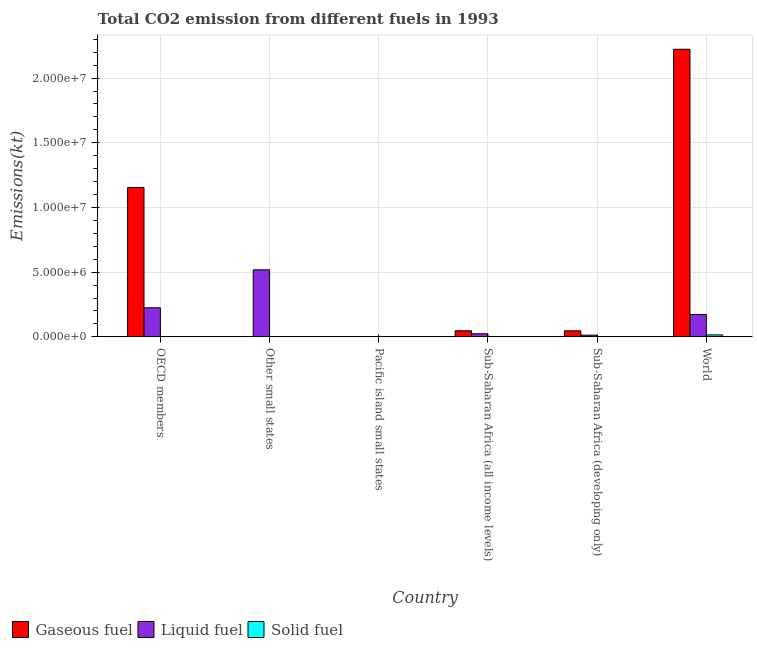How many different coloured bars are there?
Your answer should be compact. 3. How many groups of bars are there?
Provide a short and direct response. 6. Are the number of bars on each tick of the X-axis equal?
Provide a succinct answer. Yes. What is the label of the 2nd group of bars from the left?
Offer a terse response. Other small states. In how many cases, is the number of bars for a given country not equal to the number of legend labels?
Give a very brief answer. 0. What is the amount of co2 emissions from solid fuel in Sub-Saharan Africa (all income levels)?
Offer a very short reply. 2302.88. Across all countries, what is the maximum amount of co2 emissions from liquid fuel?
Your answer should be very brief. 5.18e+06. Across all countries, what is the minimum amount of co2 emissions from solid fuel?
Ensure brevity in your answer.  7.33. In which country was the amount of co2 emissions from liquid fuel maximum?
Your response must be concise. Other small states. In which country was the amount of co2 emissions from gaseous fuel minimum?
Provide a short and direct response. Pacific island small states. What is the total amount of co2 emissions from gaseous fuel in the graph?
Your answer should be very brief. 3.47e+07. What is the difference between the amount of co2 emissions from solid fuel in OECD members and that in Pacific island small states?
Your answer should be compact. -1991.18. What is the difference between the amount of co2 emissions from liquid fuel in Sub-Saharan Africa (all income levels) and the amount of co2 emissions from solid fuel in Other small states?
Your answer should be very brief. 2.39e+05. What is the average amount of co2 emissions from gaseous fuel per country?
Make the answer very short. 5.79e+06. What is the difference between the amount of co2 emissions from gaseous fuel and amount of co2 emissions from liquid fuel in Pacific island small states?
Provide a succinct answer. -6855.04. In how many countries, is the amount of co2 emissions from solid fuel greater than 3000000 kt?
Keep it short and to the point. 0. What is the ratio of the amount of co2 emissions from gaseous fuel in Other small states to that in Pacific island small states?
Your response must be concise. 9.21. What is the difference between the highest and the second highest amount of co2 emissions from liquid fuel?
Offer a very short reply. 2.93e+06. What is the difference between the highest and the lowest amount of co2 emissions from liquid fuel?
Your answer should be compact. 5.17e+06. What does the 2nd bar from the left in Sub-Saharan Africa (all income levels) represents?
Make the answer very short. Liquid fuel. What does the 2nd bar from the right in Sub-Saharan Africa (developing only) represents?
Provide a succinct answer. Liquid fuel. How many countries are there in the graph?
Your answer should be compact. 6. What is the difference between two consecutive major ticks on the Y-axis?
Keep it short and to the point. 5.00e+06. Does the graph contain grids?
Offer a very short reply. Yes. How are the legend labels stacked?
Offer a very short reply. Horizontal. What is the title of the graph?
Offer a very short reply. Total CO2 emission from different fuels in 1993. What is the label or title of the X-axis?
Keep it short and to the point. Country. What is the label or title of the Y-axis?
Keep it short and to the point. Emissions(kt). What is the Emissions(kt) in Gaseous fuel in OECD members?
Keep it short and to the point. 1.15e+07. What is the Emissions(kt) of Liquid fuel in OECD members?
Provide a short and direct response. 2.25e+06. What is the Emissions(kt) of Solid fuel in OECD members?
Provide a succinct answer. 18.34. What is the Emissions(kt) of Gaseous fuel in Other small states?
Give a very brief answer. 1.36e+04. What is the Emissions(kt) in Liquid fuel in Other small states?
Offer a very short reply. 5.18e+06. What is the Emissions(kt) of Solid fuel in Other small states?
Keep it short and to the point. 601.39. What is the Emissions(kt) of Gaseous fuel in Pacific island small states?
Give a very brief answer. 1478.82. What is the Emissions(kt) of Liquid fuel in Pacific island small states?
Keep it short and to the point. 8333.87. What is the Emissions(kt) in Solid fuel in Pacific island small states?
Give a very brief answer. 2009.52. What is the Emissions(kt) in Gaseous fuel in Sub-Saharan Africa (all income levels)?
Give a very brief answer. 4.70e+05. What is the Emissions(kt) in Liquid fuel in Sub-Saharan Africa (all income levels)?
Provide a succinct answer. 2.39e+05. What is the Emissions(kt) in Solid fuel in Sub-Saharan Africa (all income levels)?
Your answer should be compact. 2302.88. What is the Emissions(kt) of Gaseous fuel in Sub-Saharan Africa (developing only)?
Keep it short and to the point. 4.69e+05. What is the Emissions(kt) in Liquid fuel in Sub-Saharan Africa (developing only)?
Make the answer very short. 1.33e+05. What is the Emissions(kt) in Solid fuel in Sub-Saharan Africa (developing only)?
Ensure brevity in your answer.  7.33. What is the Emissions(kt) of Gaseous fuel in World?
Keep it short and to the point. 2.22e+07. What is the Emissions(kt) in Liquid fuel in World?
Provide a succinct answer. 1.73e+06. What is the Emissions(kt) of Solid fuel in World?
Offer a terse response. 1.53e+05. Across all countries, what is the maximum Emissions(kt) in Gaseous fuel?
Offer a very short reply. 2.22e+07. Across all countries, what is the maximum Emissions(kt) of Liquid fuel?
Offer a very short reply. 5.18e+06. Across all countries, what is the maximum Emissions(kt) of Solid fuel?
Your answer should be very brief. 1.53e+05. Across all countries, what is the minimum Emissions(kt) in Gaseous fuel?
Keep it short and to the point. 1478.82. Across all countries, what is the minimum Emissions(kt) of Liquid fuel?
Provide a short and direct response. 8333.87. Across all countries, what is the minimum Emissions(kt) in Solid fuel?
Keep it short and to the point. 7.33. What is the total Emissions(kt) of Gaseous fuel in the graph?
Your answer should be very brief. 3.47e+07. What is the total Emissions(kt) of Liquid fuel in the graph?
Your answer should be very brief. 9.54e+06. What is the total Emissions(kt) in Solid fuel in the graph?
Provide a short and direct response. 1.57e+05. What is the difference between the Emissions(kt) of Gaseous fuel in OECD members and that in Other small states?
Give a very brief answer. 1.15e+07. What is the difference between the Emissions(kt) of Liquid fuel in OECD members and that in Other small states?
Your answer should be compact. -2.93e+06. What is the difference between the Emissions(kt) of Solid fuel in OECD members and that in Other small states?
Ensure brevity in your answer.  -583.05. What is the difference between the Emissions(kt) of Gaseous fuel in OECD members and that in Pacific island small states?
Offer a terse response. 1.15e+07. What is the difference between the Emissions(kt) in Liquid fuel in OECD members and that in Pacific island small states?
Your response must be concise. 2.24e+06. What is the difference between the Emissions(kt) in Solid fuel in OECD members and that in Pacific island small states?
Your answer should be compact. -1991.18. What is the difference between the Emissions(kt) in Gaseous fuel in OECD members and that in Sub-Saharan Africa (all income levels)?
Ensure brevity in your answer.  1.11e+07. What is the difference between the Emissions(kt) of Liquid fuel in OECD members and that in Sub-Saharan Africa (all income levels)?
Your answer should be compact. 2.01e+06. What is the difference between the Emissions(kt) in Solid fuel in OECD members and that in Sub-Saharan Africa (all income levels)?
Make the answer very short. -2284.54. What is the difference between the Emissions(kt) of Gaseous fuel in OECD members and that in Sub-Saharan Africa (developing only)?
Offer a very short reply. 1.11e+07. What is the difference between the Emissions(kt) in Liquid fuel in OECD members and that in Sub-Saharan Africa (developing only)?
Ensure brevity in your answer.  2.12e+06. What is the difference between the Emissions(kt) in Solid fuel in OECD members and that in Sub-Saharan Africa (developing only)?
Provide a short and direct response. 11. What is the difference between the Emissions(kt) of Gaseous fuel in OECD members and that in World?
Give a very brief answer. -1.07e+07. What is the difference between the Emissions(kt) of Liquid fuel in OECD members and that in World?
Make the answer very short. 5.24e+05. What is the difference between the Emissions(kt) of Solid fuel in OECD members and that in World?
Your answer should be very brief. -1.53e+05. What is the difference between the Emissions(kt) of Gaseous fuel in Other small states and that in Pacific island small states?
Your answer should be compact. 1.21e+04. What is the difference between the Emissions(kt) of Liquid fuel in Other small states and that in Pacific island small states?
Your response must be concise. 5.17e+06. What is the difference between the Emissions(kt) in Solid fuel in Other small states and that in Pacific island small states?
Make the answer very short. -1408.13. What is the difference between the Emissions(kt) in Gaseous fuel in Other small states and that in Sub-Saharan Africa (all income levels)?
Your response must be concise. -4.56e+05. What is the difference between the Emissions(kt) in Liquid fuel in Other small states and that in Sub-Saharan Africa (all income levels)?
Give a very brief answer. 4.94e+06. What is the difference between the Emissions(kt) of Solid fuel in Other small states and that in Sub-Saharan Africa (all income levels)?
Ensure brevity in your answer.  -1701.49. What is the difference between the Emissions(kt) of Gaseous fuel in Other small states and that in Sub-Saharan Africa (developing only)?
Ensure brevity in your answer.  -4.56e+05. What is the difference between the Emissions(kt) in Liquid fuel in Other small states and that in Sub-Saharan Africa (developing only)?
Your answer should be very brief. 5.05e+06. What is the difference between the Emissions(kt) in Solid fuel in Other small states and that in Sub-Saharan Africa (developing only)?
Offer a terse response. 594.05. What is the difference between the Emissions(kt) of Gaseous fuel in Other small states and that in World?
Provide a succinct answer. -2.22e+07. What is the difference between the Emissions(kt) in Liquid fuel in Other small states and that in World?
Offer a terse response. 3.45e+06. What is the difference between the Emissions(kt) in Solid fuel in Other small states and that in World?
Offer a very short reply. -1.52e+05. What is the difference between the Emissions(kt) in Gaseous fuel in Pacific island small states and that in Sub-Saharan Africa (all income levels)?
Make the answer very short. -4.68e+05. What is the difference between the Emissions(kt) in Liquid fuel in Pacific island small states and that in Sub-Saharan Africa (all income levels)?
Make the answer very short. -2.31e+05. What is the difference between the Emissions(kt) of Solid fuel in Pacific island small states and that in Sub-Saharan Africa (all income levels)?
Make the answer very short. -293.36. What is the difference between the Emissions(kt) in Gaseous fuel in Pacific island small states and that in Sub-Saharan Africa (developing only)?
Provide a succinct answer. -4.68e+05. What is the difference between the Emissions(kt) of Liquid fuel in Pacific island small states and that in Sub-Saharan Africa (developing only)?
Offer a terse response. -1.24e+05. What is the difference between the Emissions(kt) in Solid fuel in Pacific island small states and that in Sub-Saharan Africa (developing only)?
Your response must be concise. 2002.18. What is the difference between the Emissions(kt) of Gaseous fuel in Pacific island small states and that in World?
Your answer should be compact. -2.22e+07. What is the difference between the Emissions(kt) in Liquid fuel in Pacific island small states and that in World?
Make the answer very short. -1.72e+06. What is the difference between the Emissions(kt) of Solid fuel in Pacific island small states and that in World?
Your answer should be very brief. -1.51e+05. What is the difference between the Emissions(kt) in Gaseous fuel in Sub-Saharan Africa (all income levels) and that in Sub-Saharan Africa (developing only)?
Your answer should be compact. 254.85. What is the difference between the Emissions(kt) of Liquid fuel in Sub-Saharan Africa (all income levels) and that in Sub-Saharan Africa (developing only)?
Make the answer very short. 1.07e+05. What is the difference between the Emissions(kt) in Solid fuel in Sub-Saharan Africa (all income levels) and that in Sub-Saharan Africa (developing only)?
Give a very brief answer. 2295.54. What is the difference between the Emissions(kt) in Gaseous fuel in Sub-Saharan Africa (all income levels) and that in World?
Your answer should be very brief. -2.18e+07. What is the difference between the Emissions(kt) in Liquid fuel in Sub-Saharan Africa (all income levels) and that in World?
Your answer should be very brief. -1.49e+06. What is the difference between the Emissions(kt) of Solid fuel in Sub-Saharan Africa (all income levels) and that in World?
Provide a short and direct response. -1.50e+05. What is the difference between the Emissions(kt) in Gaseous fuel in Sub-Saharan Africa (developing only) and that in World?
Keep it short and to the point. -2.18e+07. What is the difference between the Emissions(kt) in Liquid fuel in Sub-Saharan Africa (developing only) and that in World?
Offer a very short reply. -1.59e+06. What is the difference between the Emissions(kt) in Solid fuel in Sub-Saharan Africa (developing only) and that in World?
Offer a very short reply. -1.53e+05. What is the difference between the Emissions(kt) of Gaseous fuel in OECD members and the Emissions(kt) of Liquid fuel in Other small states?
Offer a terse response. 6.37e+06. What is the difference between the Emissions(kt) in Gaseous fuel in OECD members and the Emissions(kt) in Solid fuel in Other small states?
Provide a succinct answer. 1.15e+07. What is the difference between the Emissions(kt) of Liquid fuel in OECD members and the Emissions(kt) of Solid fuel in Other small states?
Offer a terse response. 2.25e+06. What is the difference between the Emissions(kt) of Gaseous fuel in OECD members and the Emissions(kt) of Liquid fuel in Pacific island small states?
Your response must be concise. 1.15e+07. What is the difference between the Emissions(kt) of Gaseous fuel in OECD members and the Emissions(kt) of Solid fuel in Pacific island small states?
Make the answer very short. 1.15e+07. What is the difference between the Emissions(kt) in Liquid fuel in OECD members and the Emissions(kt) in Solid fuel in Pacific island small states?
Provide a succinct answer. 2.25e+06. What is the difference between the Emissions(kt) in Gaseous fuel in OECD members and the Emissions(kt) in Liquid fuel in Sub-Saharan Africa (all income levels)?
Provide a succinct answer. 1.13e+07. What is the difference between the Emissions(kt) of Gaseous fuel in OECD members and the Emissions(kt) of Solid fuel in Sub-Saharan Africa (all income levels)?
Your response must be concise. 1.15e+07. What is the difference between the Emissions(kt) in Liquid fuel in OECD members and the Emissions(kt) in Solid fuel in Sub-Saharan Africa (all income levels)?
Your response must be concise. 2.25e+06. What is the difference between the Emissions(kt) of Gaseous fuel in OECD members and the Emissions(kt) of Liquid fuel in Sub-Saharan Africa (developing only)?
Offer a very short reply. 1.14e+07. What is the difference between the Emissions(kt) in Gaseous fuel in OECD members and the Emissions(kt) in Solid fuel in Sub-Saharan Africa (developing only)?
Offer a terse response. 1.15e+07. What is the difference between the Emissions(kt) in Liquid fuel in OECD members and the Emissions(kt) in Solid fuel in Sub-Saharan Africa (developing only)?
Provide a succinct answer. 2.25e+06. What is the difference between the Emissions(kt) in Gaseous fuel in OECD members and the Emissions(kt) in Liquid fuel in World?
Your response must be concise. 9.82e+06. What is the difference between the Emissions(kt) of Gaseous fuel in OECD members and the Emissions(kt) of Solid fuel in World?
Your answer should be very brief. 1.14e+07. What is the difference between the Emissions(kt) of Liquid fuel in OECD members and the Emissions(kt) of Solid fuel in World?
Your answer should be very brief. 2.10e+06. What is the difference between the Emissions(kt) of Gaseous fuel in Other small states and the Emissions(kt) of Liquid fuel in Pacific island small states?
Keep it short and to the point. 5281.11. What is the difference between the Emissions(kt) in Gaseous fuel in Other small states and the Emissions(kt) in Solid fuel in Pacific island small states?
Provide a short and direct response. 1.16e+04. What is the difference between the Emissions(kt) of Liquid fuel in Other small states and the Emissions(kt) of Solid fuel in Pacific island small states?
Give a very brief answer. 5.18e+06. What is the difference between the Emissions(kt) of Gaseous fuel in Other small states and the Emissions(kt) of Liquid fuel in Sub-Saharan Africa (all income levels)?
Your answer should be very brief. -2.26e+05. What is the difference between the Emissions(kt) of Gaseous fuel in Other small states and the Emissions(kt) of Solid fuel in Sub-Saharan Africa (all income levels)?
Make the answer very short. 1.13e+04. What is the difference between the Emissions(kt) in Liquid fuel in Other small states and the Emissions(kt) in Solid fuel in Sub-Saharan Africa (all income levels)?
Give a very brief answer. 5.18e+06. What is the difference between the Emissions(kt) of Gaseous fuel in Other small states and the Emissions(kt) of Liquid fuel in Sub-Saharan Africa (developing only)?
Make the answer very short. -1.19e+05. What is the difference between the Emissions(kt) of Gaseous fuel in Other small states and the Emissions(kt) of Solid fuel in Sub-Saharan Africa (developing only)?
Your response must be concise. 1.36e+04. What is the difference between the Emissions(kt) in Liquid fuel in Other small states and the Emissions(kt) in Solid fuel in Sub-Saharan Africa (developing only)?
Your answer should be very brief. 5.18e+06. What is the difference between the Emissions(kt) in Gaseous fuel in Other small states and the Emissions(kt) in Liquid fuel in World?
Your response must be concise. -1.71e+06. What is the difference between the Emissions(kt) of Gaseous fuel in Other small states and the Emissions(kt) of Solid fuel in World?
Offer a terse response. -1.39e+05. What is the difference between the Emissions(kt) of Liquid fuel in Other small states and the Emissions(kt) of Solid fuel in World?
Make the answer very short. 5.03e+06. What is the difference between the Emissions(kt) of Gaseous fuel in Pacific island small states and the Emissions(kt) of Liquid fuel in Sub-Saharan Africa (all income levels)?
Give a very brief answer. -2.38e+05. What is the difference between the Emissions(kt) of Gaseous fuel in Pacific island small states and the Emissions(kt) of Solid fuel in Sub-Saharan Africa (all income levels)?
Provide a succinct answer. -824.05. What is the difference between the Emissions(kt) of Liquid fuel in Pacific island small states and the Emissions(kt) of Solid fuel in Sub-Saharan Africa (all income levels)?
Offer a terse response. 6030.99. What is the difference between the Emissions(kt) of Gaseous fuel in Pacific island small states and the Emissions(kt) of Liquid fuel in Sub-Saharan Africa (developing only)?
Offer a very short reply. -1.31e+05. What is the difference between the Emissions(kt) of Gaseous fuel in Pacific island small states and the Emissions(kt) of Solid fuel in Sub-Saharan Africa (developing only)?
Keep it short and to the point. 1471.49. What is the difference between the Emissions(kt) in Liquid fuel in Pacific island small states and the Emissions(kt) in Solid fuel in Sub-Saharan Africa (developing only)?
Offer a terse response. 8326.53. What is the difference between the Emissions(kt) of Gaseous fuel in Pacific island small states and the Emissions(kt) of Liquid fuel in World?
Give a very brief answer. -1.72e+06. What is the difference between the Emissions(kt) in Gaseous fuel in Pacific island small states and the Emissions(kt) in Solid fuel in World?
Ensure brevity in your answer.  -1.51e+05. What is the difference between the Emissions(kt) of Liquid fuel in Pacific island small states and the Emissions(kt) of Solid fuel in World?
Give a very brief answer. -1.44e+05. What is the difference between the Emissions(kt) of Gaseous fuel in Sub-Saharan Africa (all income levels) and the Emissions(kt) of Liquid fuel in Sub-Saharan Africa (developing only)?
Ensure brevity in your answer.  3.37e+05. What is the difference between the Emissions(kt) in Gaseous fuel in Sub-Saharan Africa (all income levels) and the Emissions(kt) in Solid fuel in Sub-Saharan Africa (developing only)?
Give a very brief answer. 4.70e+05. What is the difference between the Emissions(kt) of Liquid fuel in Sub-Saharan Africa (all income levels) and the Emissions(kt) of Solid fuel in Sub-Saharan Africa (developing only)?
Your answer should be very brief. 2.39e+05. What is the difference between the Emissions(kt) in Gaseous fuel in Sub-Saharan Africa (all income levels) and the Emissions(kt) in Liquid fuel in World?
Offer a very short reply. -1.26e+06. What is the difference between the Emissions(kt) of Gaseous fuel in Sub-Saharan Africa (all income levels) and the Emissions(kt) of Solid fuel in World?
Your answer should be compact. 3.17e+05. What is the difference between the Emissions(kt) in Liquid fuel in Sub-Saharan Africa (all income levels) and the Emissions(kt) in Solid fuel in World?
Give a very brief answer. 8.66e+04. What is the difference between the Emissions(kt) in Gaseous fuel in Sub-Saharan Africa (developing only) and the Emissions(kt) in Liquid fuel in World?
Provide a succinct answer. -1.26e+06. What is the difference between the Emissions(kt) in Gaseous fuel in Sub-Saharan Africa (developing only) and the Emissions(kt) in Solid fuel in World?
Keep it short and to the point. 3.17e+05. What is the difference between the Emissions(kt) in Liquid fuel in Sub-Saharan Africa (developing only) and the Emissions(kt) in Solid fuel in World?
Provide a short and direct response. -2.00e+04. What is the average Emissions(kt) in Gaseous fuel per country?
Your response must be concise. 5.79e+06. What is the average Emissions(kt) of Liquid fuel per country?
Keep it short and to the point. 1.59e+06. What is the average Emissions(kt) of Solid fuel per country?
Your answer should be very brief. 2.62e+04. What is the difference between the Emissions(kt) in Gaseous fuel and Emissions(kt) in Liquid fuel in OECD members?
Offer a very short reply. 9.30e+06. What is the difference between the Emissions(kt) of Gaseous fuel and Emissions(kt) of Solid fuel in OECD members?
Give a very brief answer. 1.15e+07. What is the difference between the Emissions(kt) of Liquid fuel and Emissions(kt) of Solid fuel in OECD members?
Your answer should be compact. 2.25e+06. What is the difference between the Emissions(kt) of Gaseous fuel and Emissions(kt) of Liquid fuel in Other small states?
Your answer should be very brief. -5.17e+06. What is the difference between the Emissions(kt) of Gaseous fuel and Emissions(kt) of Solid fuel in Other small states?
Your answer should be compact. 1.30e+04. What is the difference between the Emissions(kt) in Liquid fuel and Emissions(kt) in Solid fuel in Other small states?
Your response must be concise. 5.18e+06. What is the difference between the Emissions(kt) in Gaseous fuel and Emissions(kt) in Liquid fuel in Pacific island small states?
Your answer should be compact. -6855.04. What is the difference between the Emissions(kt) in Gaseous fuel and Emissions(kt) in Solid fuel in Pacific island small states?
Give a very brief answer. -530.69. What is the difference between the Emissions(kt) in Liquid fuel and Emissions(kt) in Solid fuel in Pacific island small states?
Give a very brief answer. 6324.35. What is the difference between the Emissions(kt) in Gaseous fuel and Emissions(kt) in Liquid fuel in Sub-Saharan Africa (all income levels)?
Offer a terse response. 2.30e+05. What is the difference between the Emissions(kt) in Gaseous fuel and Emissions(kt) in Solid fuel in Sub-Saharan Africa (all income levels)?
Your response must be concise. 4.67e+05. What is the difference between the Emissions(kt) of Liquid fuel and Emissions(kt) of Solid fuel in Sub-Saharan Africa (all income levels)?
Your answer should be very brief. 2.37e+05. What is the difference between the Emissions(kt) in Gaseous fuel and Emissions(kt) in Liquid fuel in Sub-Saharan Africa (developing only)?
Your answer should be very brief. 3.37e+05. What is the difference between the Emissions(kt) in Gaseous fuel and Emissions(kt) in Solid fuel in Sub-Saharan Africa (developing only)?
Keep it short and to the point. 4.69e+05. What is the difference between the Emissions(kt) in Liquid fuel and Emissions(kt) in Solid fuel in Sub-Saharan Africa (developing only)?
Keep it short and to the point. 1.33e+05. What is the difference between the Emissions(kt) in Gaseous fuel and Emissions(kt) in Liquid fuel in World?
Your response must be concise. 2.05e+07. What is the difference between the Emissions(kt) of Gaseous fuel and Emissions(kt) of Solid fuel in World?
Give a very brief answer. 2.21e+07. What is the difference between the Emissions(kt) of Liquid fuel and Emissions(kt) of Solid fuel in World?
Offer a very short reply. 1.57e+06. What is the ratio of the Emissions(kt) of Gaseous fuel in OECD members to that in Other small states?
Your answer should be very brief. 848.19. What is the ratio of the Emissions(kt) in Liquid fuel in OECD members to that in Other small states?
Give a very brief answer. 0.43. What is the ratio of the Emissions(kt) in Solid fuel in OECD members to that in Other small states?
Your answer should be very brief. 0.03. What is the ratio of the Emissions(kt) in Gaseous fuel in OECD members to that in Pacific island small states?
Keep it short and to the point. 7809. What is the ratio of the Emissions(kt) in Liquid fuel in OECD members to that in Pacific island small states?
Keep it short and to the point. 269.99. What is the ratio of the Emissions(kt) in Solid fuel in OECD members to that in Pacific island small states?
Your answer should be compact. 0.01. What is the ratio of the Emissions(kt) of Gaseous fuel in OECD members to that in Sub-Saharan Africa (all income levels)?
Your answer should be compact. 24.59. What is the ratio of the Emissions(kt) of Liquid fuel in OECD members to that in Sub-Saharan Africa (all income levels)?
Your answer should be compact. 9.41. What is the ratio of the Emissions(kt) in Solid fuel in OECD members to that in Sub-Saharan Africa (all income levels)?
Your answer should be very brief. 0.01. What is the ratio of the Emissions(kt) of Gaseous fuel in OECD members to that in Sub-Saharan Africa (developing only)?
Offer a very short reply. 24.61. What is the ratio of the Emissions(kt) in Liquid fuel in OECD members to that in Sub-Saharan Africa (developing only)?
Ensure brevity in your answer.  16.97. What is the ratio of the Emissions(kt) of Solid fuel in OECD members to that in Sub-Saharan Africa (developing only)?
Offer a terse response. 2.5. What is the ratio of the Emissions(kt) in Gaseous fuel in OECD members to that in World?
Provide a succinct answer. 0.52. What is the ratio of the Emissions(kt) in Liquid fuel in OECD members to that in World?
Your answer should be compact. 1.3. What is the ratio of the Emissions(kt) of Solid fuel in OECD members to that in World?
Give a very brief answer. 0. What is the ratio of the Emissions(kt) in Gaseous fuel in Other small states to that in Pacific island small states?
Make the answer very short. 9.21. What is the ratio of the Emissions(kt) in Liquid fuel in Other small states to that in Pacific island small states?
Provide a succinct answer. 621.65. What is the ratio of the Emissions(kt) in Solid fuel in Other small states to that in Pacific island small states?
Your answer should be very brief. 0.3. What is the ratio of the Emissions(kt) in Gaseous fuel in Other small states to that in Sub-Saharan Africa (all income levels)?
Make the answer very short. 0.03. What is the ratio of the Emissions(kt) of Liquid fuel in Other small states to that in Sub-Saharan Africa (all income levels)?
Offer a very short reply. 21.66. What is the ratio of the Emissions(kt) of Solid fuel in Other small states to that in Sub-Saharan Africa (all income levels)?
Keep it short and to the point. 0.26. What is the ratio of the Emissions(kt) of Gaseous fuel in Other small states to that in Sub-Saharan Africa (developing only)?
Your answer should be compact. 0.03. What is the ratio of the Emissions(kt) in Liquid fuel in Other small states to that in Sub-Saharan Africa (developing only)?
Provide a short and direct response. 39.08. What is the ratio of the Emissions(kt) of Gaseous fuel in Other small states to that in World?
Your answer should be compact. 0. What is the ratio of the Emissions(kt) in Liquid fuel in Other small states to that in World?
Keep it short and to the point. 3. What is the ratio of the Emissions(kt) of Solid fuel in Other small states to that in World?
Your response must be concise. 0. What is the ratio of the Emissions(kt) of Gaseous fuel in Pacific island small states to that in Sub-Saharan Africa (all income levels)?
Make the answer very short. 0. What is the ratio of the Emissions(kt) in Liquid fuel in Pacific island small states to that in Sub-Saharan Africa (all income levels)?
Offer a very short reply. 0.03. What is the ratio of the Emissions(kt) in Solid fuel in Pacific island small states to that in Sub-Saharan Africa (all income levels)?
Make the answer very short. 0.87. What is the ratio of the Emissions(kt) in Gaseous fuel in Pacific island small states to that in Sub-Saharan Africa (developing only)?
Offer a terse response. 0. What is the ratio of the Emissions(kt) in Liquid fuel in Pacific island small states to that in Sub-Saharan Africa (developing only)?
Your response must be concise. 0.06. What is the ratio of the Emissions(kt) in Solid fuel in Pacific island small states to that in Sub-Saharan Africa (developing only)?
Ensure brevity in your answer.  274. What is the ratio of the Emissions(kt) in Liquid fuel in Pacific island small states to that in World?
Provide a short and direct response. 0. What is the ratio of the Emissions(kt) in Solid fuel in Pacific island small states to that in World?
Give a very brief answer. 0.01. What is the ratio of the Emissions(kt) in Liquid fuel in Sub-Saharan Africa (all income levels) to that in Sub-Saharan Africa (developing only)?
Give a very brief answer. 1.8. What is the ratio of the Emissions(kt) in Solid fuel in Sub-Saharan Africa (all income levels) to that in Sub-Saharan Africa (developing only)?
Your answer should be very brief. 314. What is the ratio of the Emissions(kt) in Gaseous fuel in Sub-Saharan Africa (all income levels) to that in World?
Your response must be concise. 0.02. What is the ratio of the Emissions(kt) of Liquid fuel in Sub-Saharan Africa (all income levels) to that in World?
Provide a succinct answer. 0.14. What is the ratio of the Emissions(kt) of Solid fuel in Sub-Saharan Africa (all income levels) to that in World?
Provide a short and direct response. 0.02. What is the ratio of the Emissions(kt) of Gaseous fuel in Sub-Saharan Africa (developing only) to that in World?
Make the answer very short. 0.02. What is the ratio of the Emissions(kt) of Liquid fuel in Sub-Saharan Africa (developing only) to that in World?
Offer a very short reply. 0.08. What is the difference between the highest and the second highest Emissions(kt) of Gaseous fuel?
Ensure brevity in your answer.  1.07e+07. What is the difference between the highest and the second highest Emissions(kt) of Liquid fuel?
Ensure brevity in your answer.  2.93e+06. What is the difference between the highest and the second highest Emissions(kt) of Solid fuel?
Your answer should be very brief. 1.50e+05. What is the difference between the highest and the lowest Emissions(kt) of Gaseous fuel?
Ensure brevity in your answer.  2.22e+07. What is the difference between the highest and the lowest Emissions(kt) of Liquid fuel?
Provide a short and direct response. 5.17e+06. What is the difference between the highest and the lowest Emissions(kt) of Solid fuel?
Offer a very short reply. 1.53e+05. 